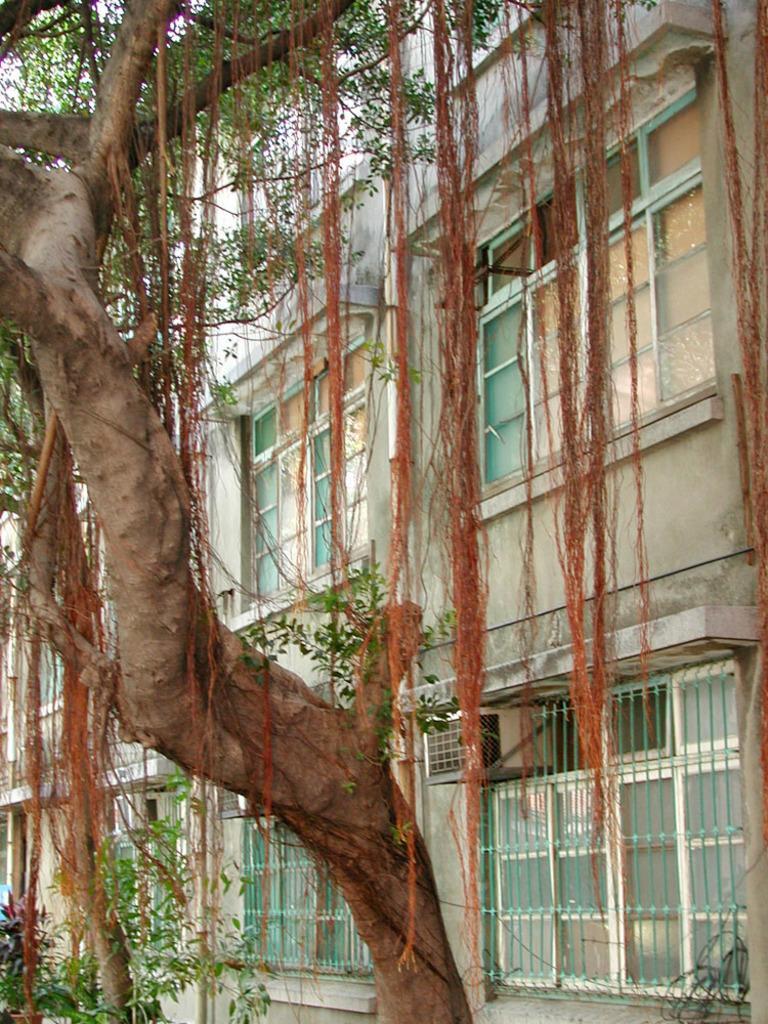Describe this image in one or two sentences. This picture is clicked outside. On the left we can see the trunk and branches of a tree. On the right there is a building and we can see the windows of the building and we can see some other items. 